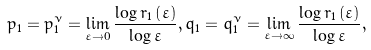<formula> <loc_0><loc_0><loc_500><loc_500>p _ { 1 } = p _ { 1 } ^ { \nu } = \lim _ { \varepsilon \rightarrow 0 } \frac { \log r _ { 1 } \left ( \varepsilon \right ) } { \log \varepsilon } , q _ { 1 } = q _ { 1 } ^ { \nu } = \lim _ { \varepsilon \rightarrow \infty } \frac { \log r _ { 1 } \left ( \varepsilon \right ) } { \log \varepsilon } ,</formula> 